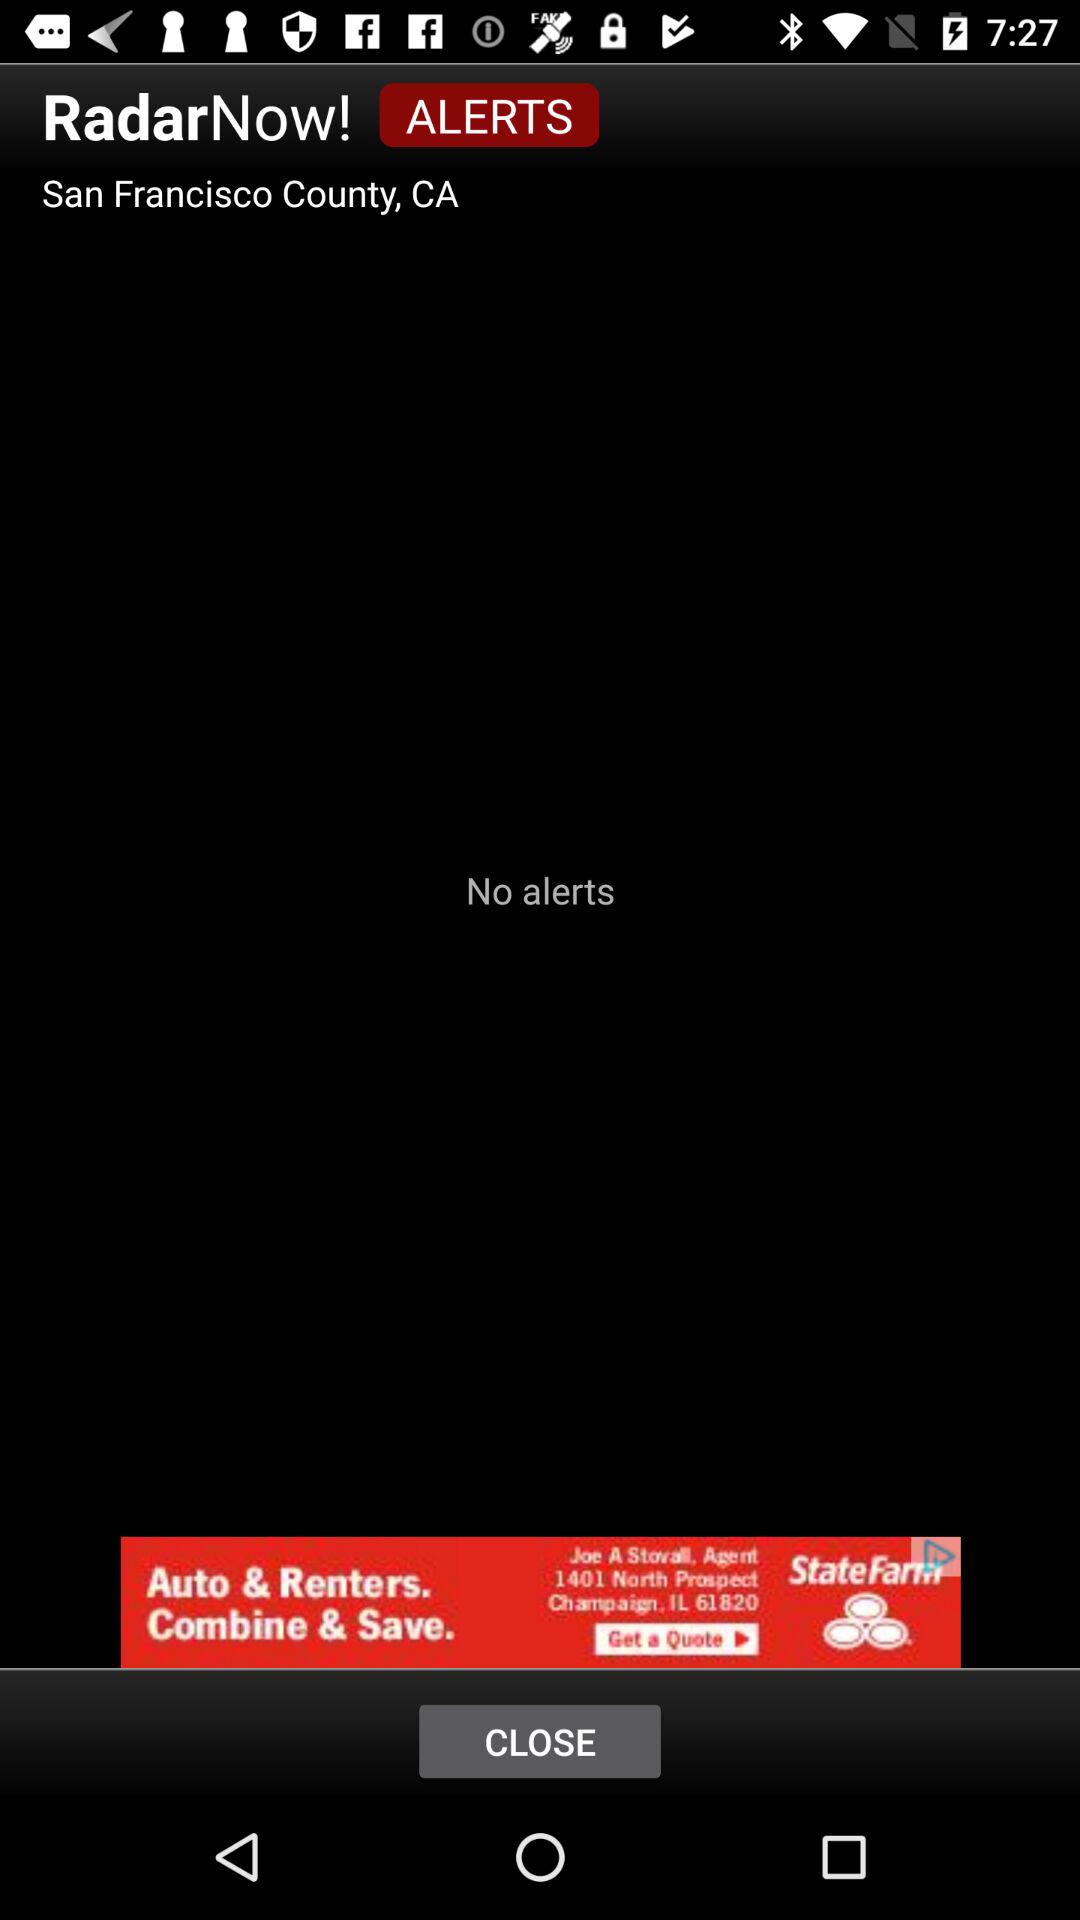Where does the alert notification come from?
When the provided information is insufficient, respond with <no answer>. <no answer> 